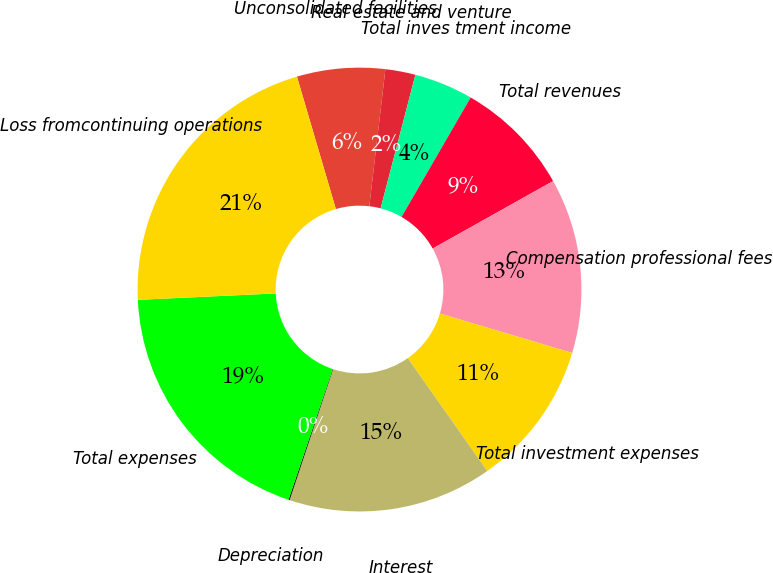Convert chart. <chart><loc_0><loc_0><loc_500><loc_500><pie_chart><fcel>Unconsolidated facilities<fcel>Real estate and venture<fcel>Total inves tment income<fcel>Total revenues<fcel>Compensation professional fees<fcel>Total investment expenses<fcel>Interest<fcel>Depreciation<fcel>Total expenses<fcel>Loss fromcontinuing operations<nl><fcel>6.41%<fcel>2.19%<fcel>4.3%<fcel>8.52%<fcel>12.74%<fcel>10.63%<fcel>14.86%<fcel>0.08%<fcel>19.08%<fcel>21.19%<nl></chart> 